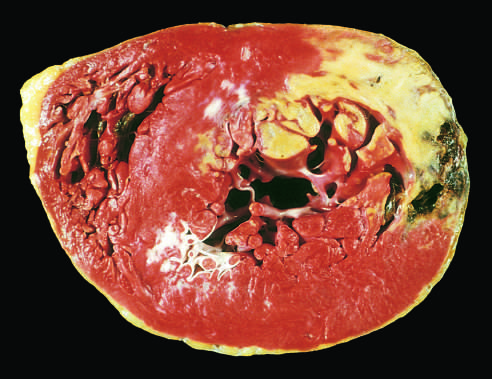s the moderate-power view of the plaque demonstrated by a lack of triphenyltetrazolium chloride staining in areas of necrosis?
Answer the question using a single word or phrase. No 